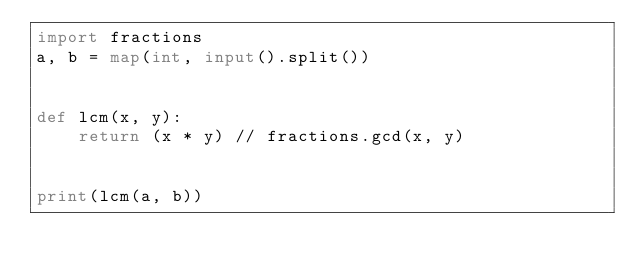Convert code to text. <code><loc_0><loc_0><loc_500><loc_500><_Python_>import fractions
a, b = map(int, input().split())


def lcm(x, y):
    return (x * y) // fractions.gcd(x, y)


print(lcm(a, b))</code> 